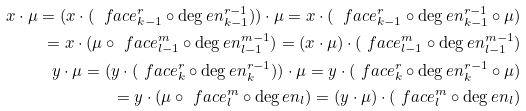<formula> <loc_0><loc_0><loc_500><loc_500>x \cdot \mu = ( x \cdot ( \ f a c e ^ { r } _ { k - 1 } \circ \deg e n ^ { r - 1 } _ { k - 1 } ) ) \cdot \mu = x \cdot ( \ f a c e ^ { r } _ { k - 1 } \circ \deg e n ^ { r - 1 } _ { k - 1 } \circ \mu ) \\ = x \cdot ( \mu \circ \ f a c e ^ { m } _ { l - 1 } \circ \deg e n ^ { m - 1 } _ { l - 1 } ) = ( x \cdot \mu ) \cdot ( \ f a c e ^ { m } _ { l - 1 } \circ \deg e n ^ { m - 1 } _ { l - 1 } ) \\ y \cdot \mu = ( y \cdot ( \ f a c e ^ { r } _ { k } \circ \deg e n ^ { r - 1 } _ { k } ) ) \cdot \mu = y \cdot ( \ f a c e ^ { r } _ { k } \circ \deg e n ^ { r - 1 } _ { k } \circ \mu ) \\ = y \cdot ( \mu \circ \ f a c e ^ { m } _ { l } \circ \deg e n _ { l } ) = ( y \cdot \mu ) \cdot ( \ f a c e ^ { m } _ { l } \circ \deg e n _ { l } )</formula> 